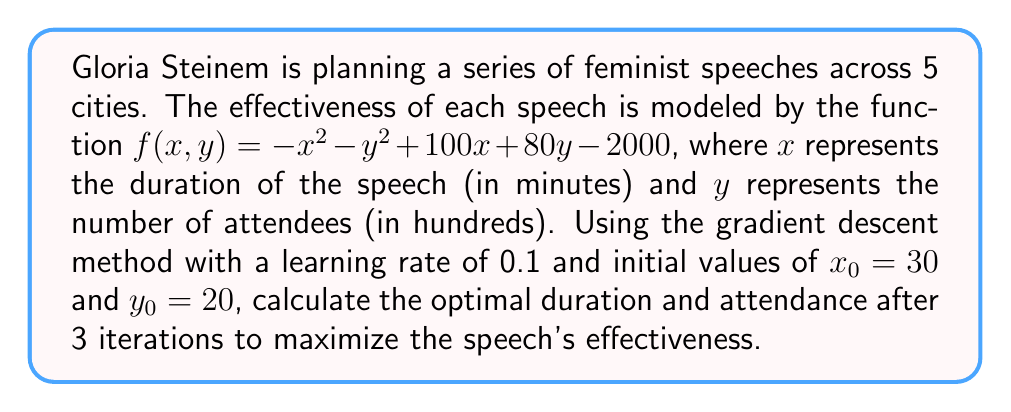Could you help me with this problem? To solve this optimization problem using gradient descent, we follow these steps:

1) First, we need to calculate the gradient of $f(x,y)$:
   $$\nabla f(x,y) = \begin{bmatrix}
   \frac{\partial f}{\partial x} \\
   \frac{\partial f}{\partial y}
   \end{bmatrix} = \begin{bmatrix}
   -2x + 100 \\
   -2y + 80
   \end{bmatrix}$$

2) The update rule for gradient descent is:
   $$\begin{bmatrix} x_{n+1} \\ y_{n+1} \end{bmatrix} = \begin{bmatrix} x_n \\ y_n \end{bmatrix} + \alpha \nabla f(x_n, y_n)$$
   where $\alpha = 0.1$ is the learning rate.

3) Now, let's perform 3 iterations:

   Iteration 1:
   $$\nabla f(30, 20) = \begin{bmatrix} -60 + 100 \\ -40 + 80 \end{bmatrix} = \begin{bmatrix} 40 \\ 40 \end{bmatrix}$$
   $$\begin{bmatrix} x_1 \\ y_1 \end{bmatrix} = \begin{bmatrix} 30 \\ 20 \end{bmatrix} + 0.1 \begin{bmatrix} 40 \\ 40 \end{bmatrix} = \begin{bmatrix} 34 \\ 24 \end{bmatrix}$$

   Iteration 2:
   $$\nabla f(34, 24) = \begin{bmatrix} -68 + 100 \\ -48 + 80 \end{bmatrix} = \begin{bmatrix} 32 \\ 32 \end{bmatrix}$$
   $$\begin{bmatrix} x_2 \\ y_2 \end{bmatrix} = \begin{bmatrix} 34 \\ 24 \end{bmatrix} + 0.1 \begin{bmatrix} 32 \\ 32 \end{bmatrix} = \begin{bmatrix} 37.2 \\ 27.2 \end{bmatrix}$$

   Iteration 3:
   $$\nabla f(37.2, 27.2) = \begin{bmatrix} -74.4 + 100 \\ -54.4 + 80 \end{bmatrix} = \begin{bmatrix} 25.6 \\ 25.6 \end{bmatrix}$$
   $$\begin{bmatrix} x_3 \\ y_3 \end{bmatrix} = \begin{bmatrix} 37.2 \\ 27.2 \end{bmatrix} + 0.1 \begin{bmatrix} 25.6 \\ 25.6 \end{bmatrix} = \begin{bmatrix} 39.76 \\ 29.76 \end{bmatrix}$$

4) Therefore, after 3 iterations, the optimal duration is approximately 39.76 minutes and the optimal attendance is approximately 2976 people.
Answer: (39.76, 2976) 